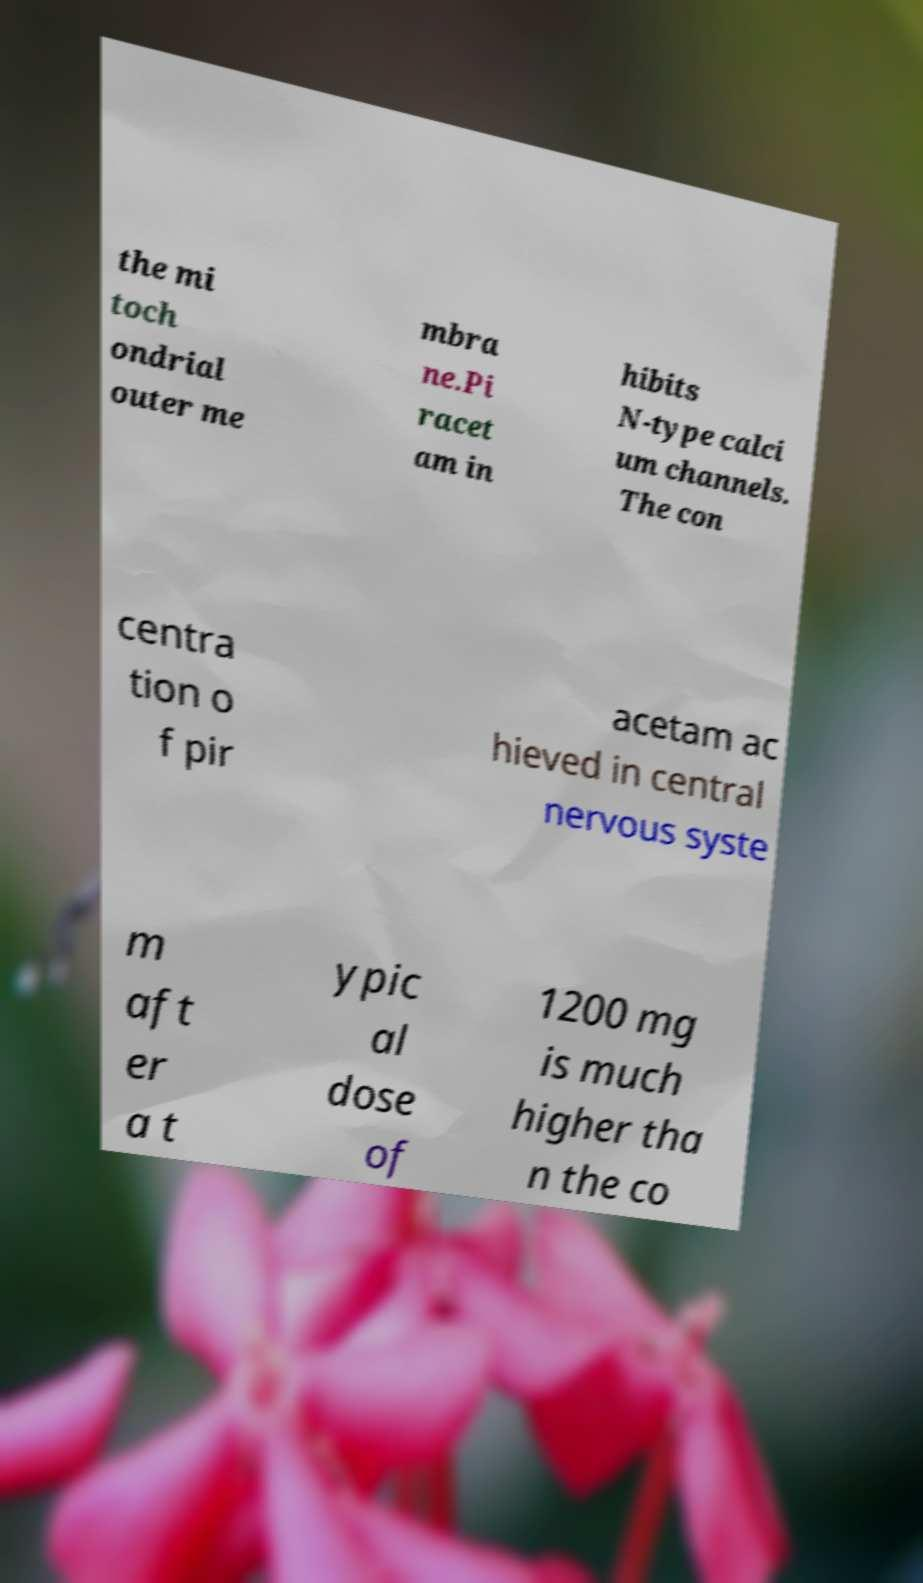Could you assist in decoding the text presented in this image and type it out clearly? the mi toch ondrial outer me mbra ne.Pi racet am in hibits N-type calci um channels. The con centra tion o f pir acetam ac hieved in central nervous syste m aft er a t ypic al dose of 1200 mg is much higher tha n the co 